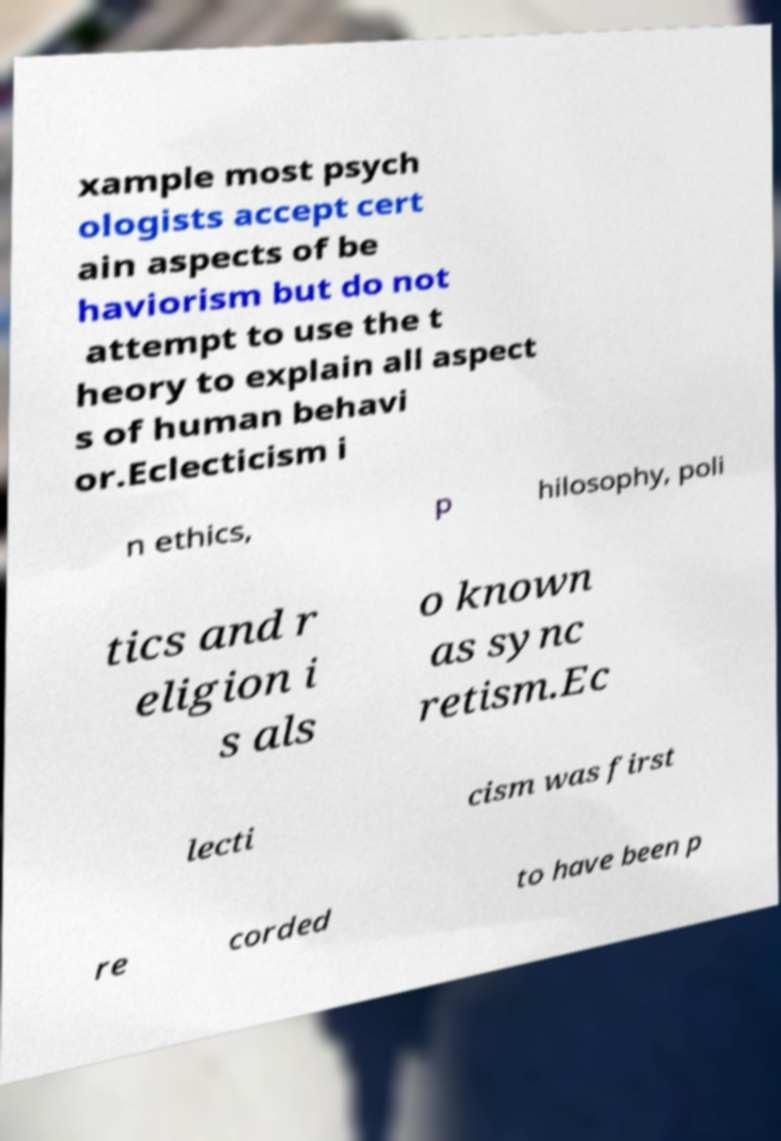Please read and relay the text visible in this image. What does it say? xample most psych ologists accept cert ain aspects of be haviorism but do not attempt to use the t heory to explain all aspect s of human behavi or.Eclecticism i n ethics, p hilosophy, poli tics and r eligion i s als o known as sync retism.Ec lecti cism was first re corded to have been p 